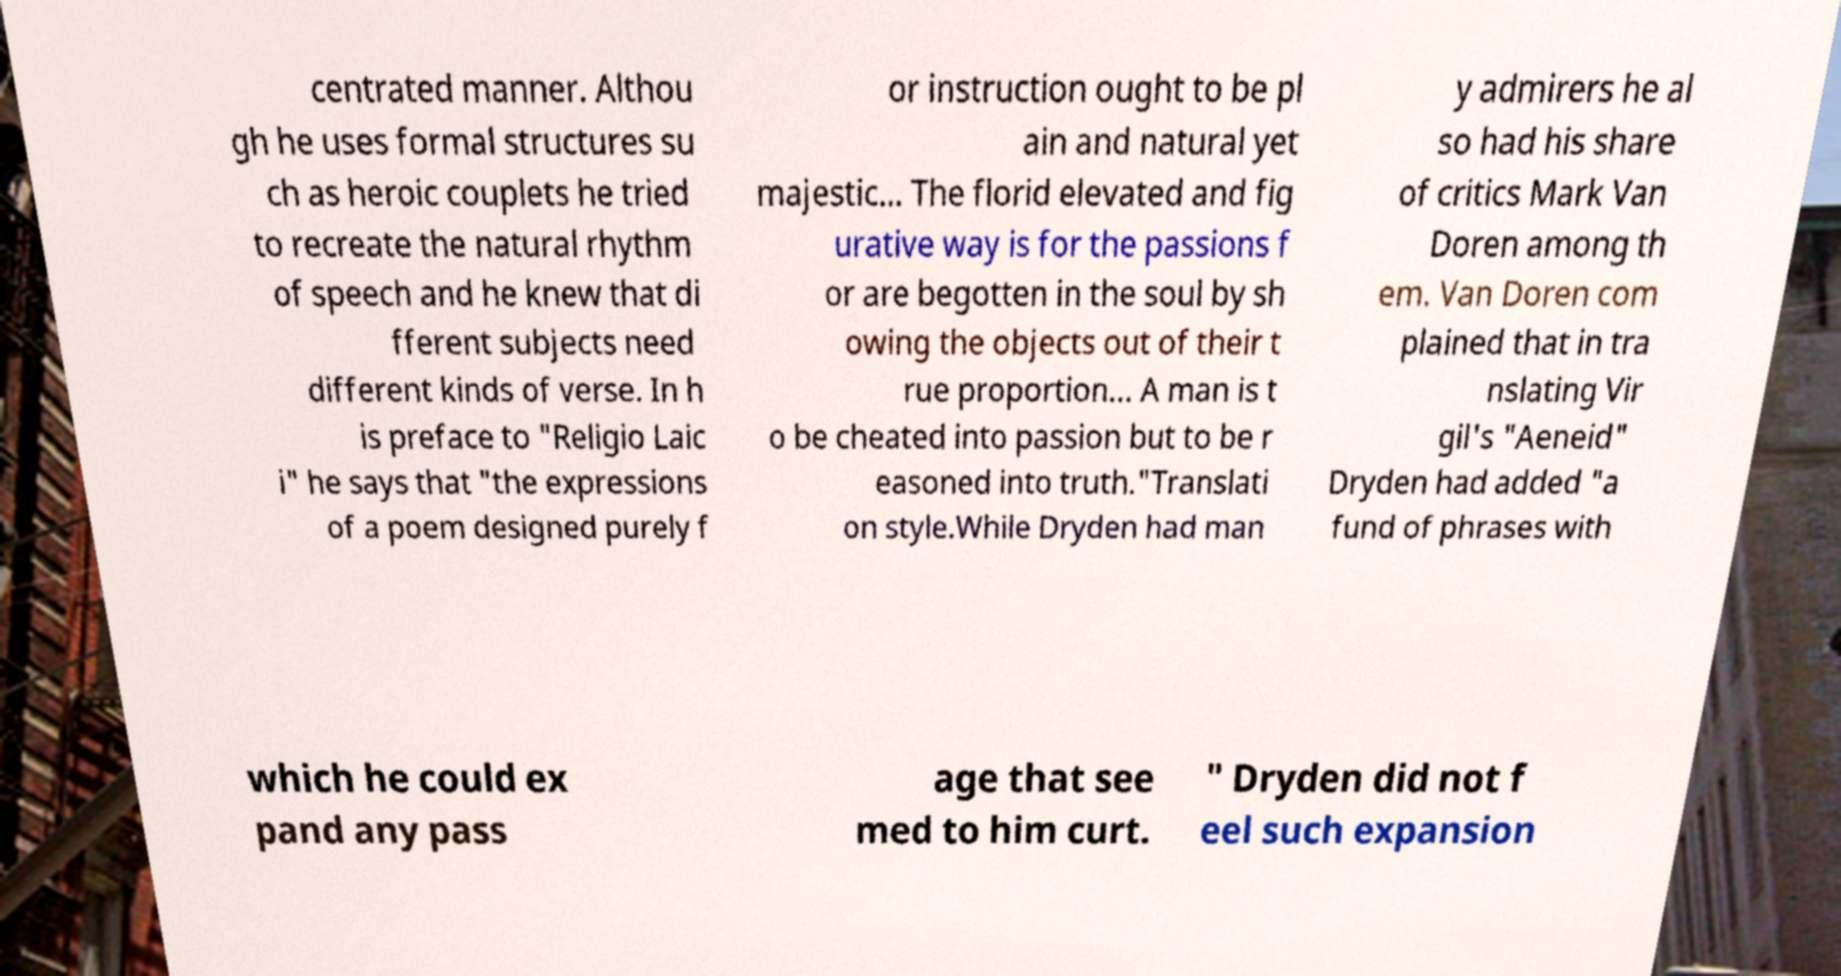For documentation purposes, I need the text within this image transcribed. Could you provide that? centrated manner. Althou gh he uses formal structures su ch as heroic couplets he tried to recreate the natural rhythm of speech and he knew that di fferent subjects need different kinds of verse. In h is preface to "Religio Laic i" he says that "the expressions of a poem designed purely f or instruction ought to be pl ain and natural yet majestic... The florid elevated and fig urative way is for the passions f or are begotten in the soul by sh owing the objects out of their t rue proportion... A man is t o be cheated into passion but to be r easoned into truth."Translati on style.While Dryden had man y admirers he al so had his share of critics Mark Van Doren among th em. Van Doren com plained that in tra nslating Vir gil's "Aeneid" Dryden had added "a fund of phrases with which he could ex pand any pass age that see med to him curt. " Dryden did not f eel such expansion 